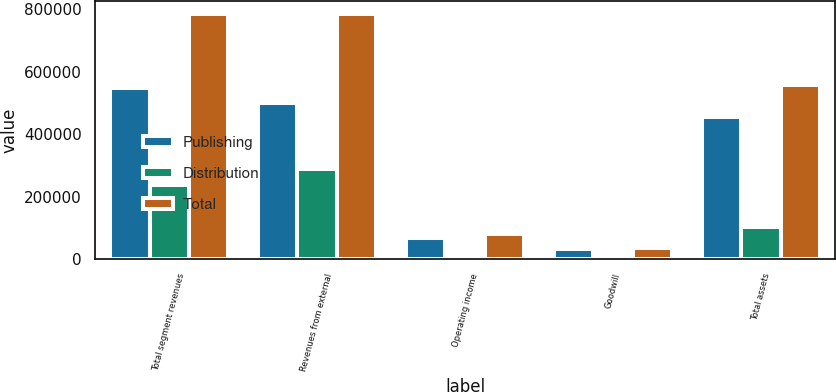Convert chart. <chart><loc_0><loc_0><loc_500><loc_500><stacked_bar_chart><ecel><fcel>Total segment revenues<fcel>Revenues from external<fcel>Operating income<fcel>Goodwill<fcel>Total assets<nl><fcel>Publishing<fcel>549508<fcel>498876<fcel>68675<fcel>31626<fcel>455432<nl><fcel>Distribution<fcel>236926<fcel>287558<fcel>11899<fcel>4366<fcel>101455<nl><fcel>Total<fcel>786434<fcel>786434<fcel>80574<fcel>35992<fcel>556887<nl></chart> 